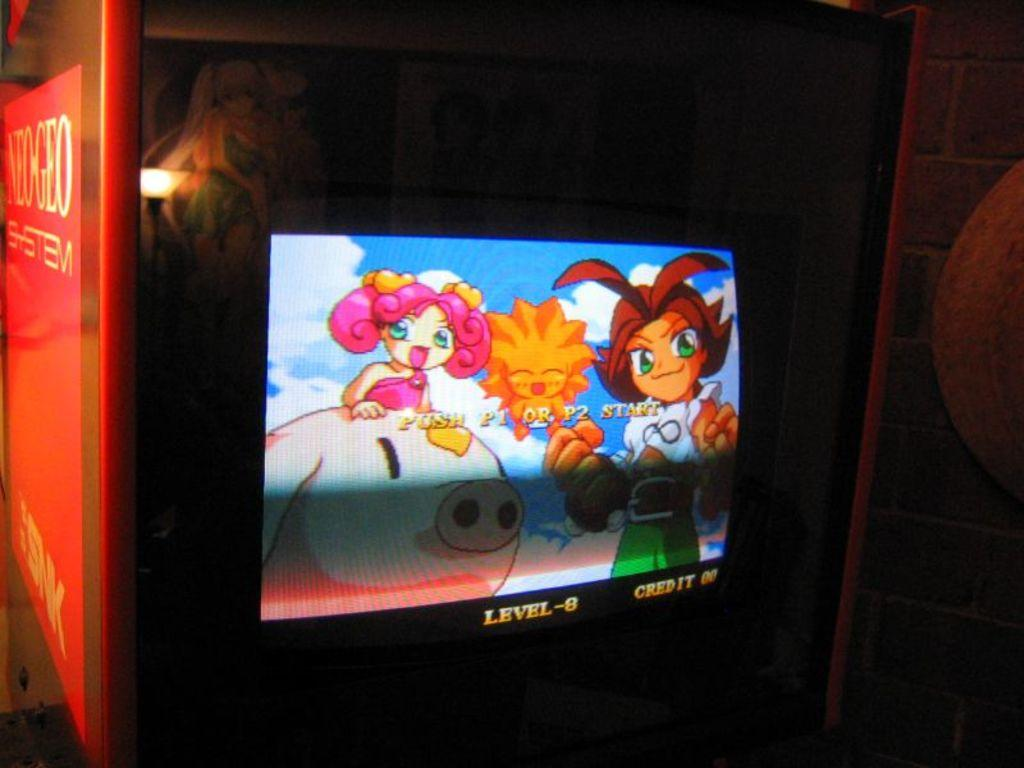<image>
Share a concise interpretation of the image provided. the word level is on the front of a television with characters 